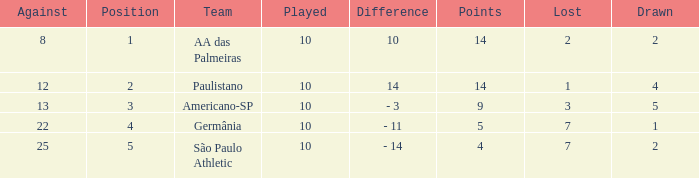What is the highest Drawn when the lost is 7 and the points are more than 4, and the against is less than 22? None. 